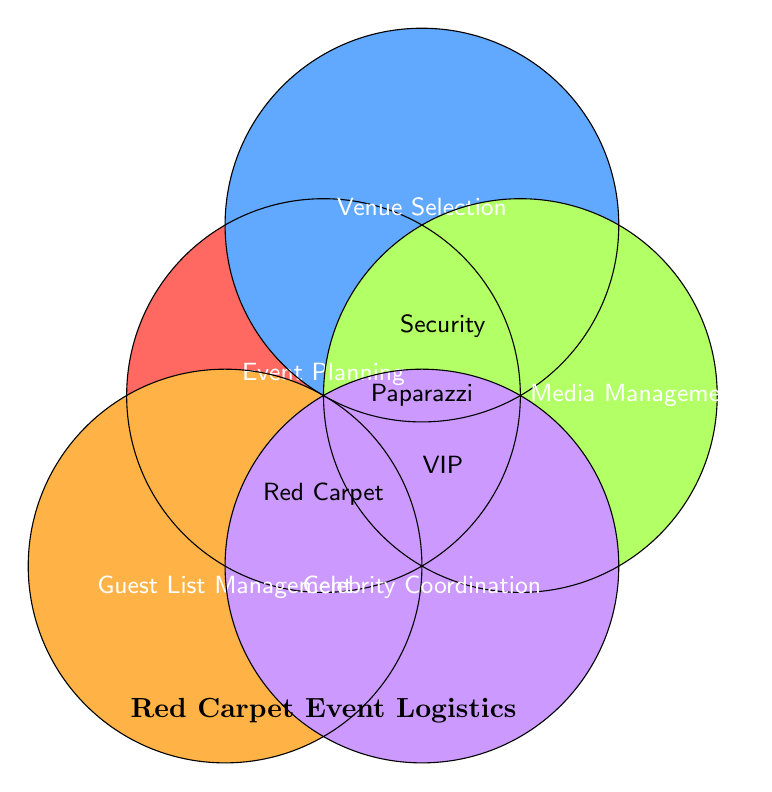What are the five main elements in the Venn Diagram? The elements are the labels of the circles in the Venn diagram. Each circle represents a different logistic aspect.
Answer: Event Planning, Venue Selection, Media Management, Guest List Management, Celebrity Coordination Which logistic aspect intersects all other aspects? By visually inspecting the Venn Diagram, the element in the center intersects all circles.
Answer: Event Planning Which logistic aspects overlap with Media Management? By looking at the Venn Diagram, we see which circles intersect with Media Management.
Answer: Event Planning, Venue Selection, Celebrity Coordination What logistic aspects share Media Management and Guest List Management? Analyze the diagram to ensure both Media Management and Guest List Management circles have a shared area.
Answer: Event Planning Which logistic aspect is responsible for VIP Treatment? Check the segments of the Venn Diagram labeled with VIP Treatment to identify the corresponding logistic aspect.
Answer: Guest List Management How is Security Responsibility shared among logistic aspects? Identify the region in the Venn Diagram labeled Security and observe overlapping circles.
Answer: Venue Selection, Media Management Are media-related aspects managed by Media Management alone? Compare the intersections and see if other categories share media-related duties.
Answer: No Which logistic aspect coordinates Paparazzi Control? Find the shared area labeled Paparazzi Control on the Venn Diagram to see which logistic aspects intersect.
Answer: Media Management, Celebrity Coordination What does the Red Carpet Layout logistics overlap with? Look at the part of the Venn Diagram where Red Carpet Layout is labeled. Identify intersecting logistics.
Answer: Venue Selection, Guest List Management Which two logistics aspects are clearly divided without any intersection? Inspect the Venn Diagram to find any two logistic aspects that do not share any common region.
Answer: Guest List Management, Media Management 